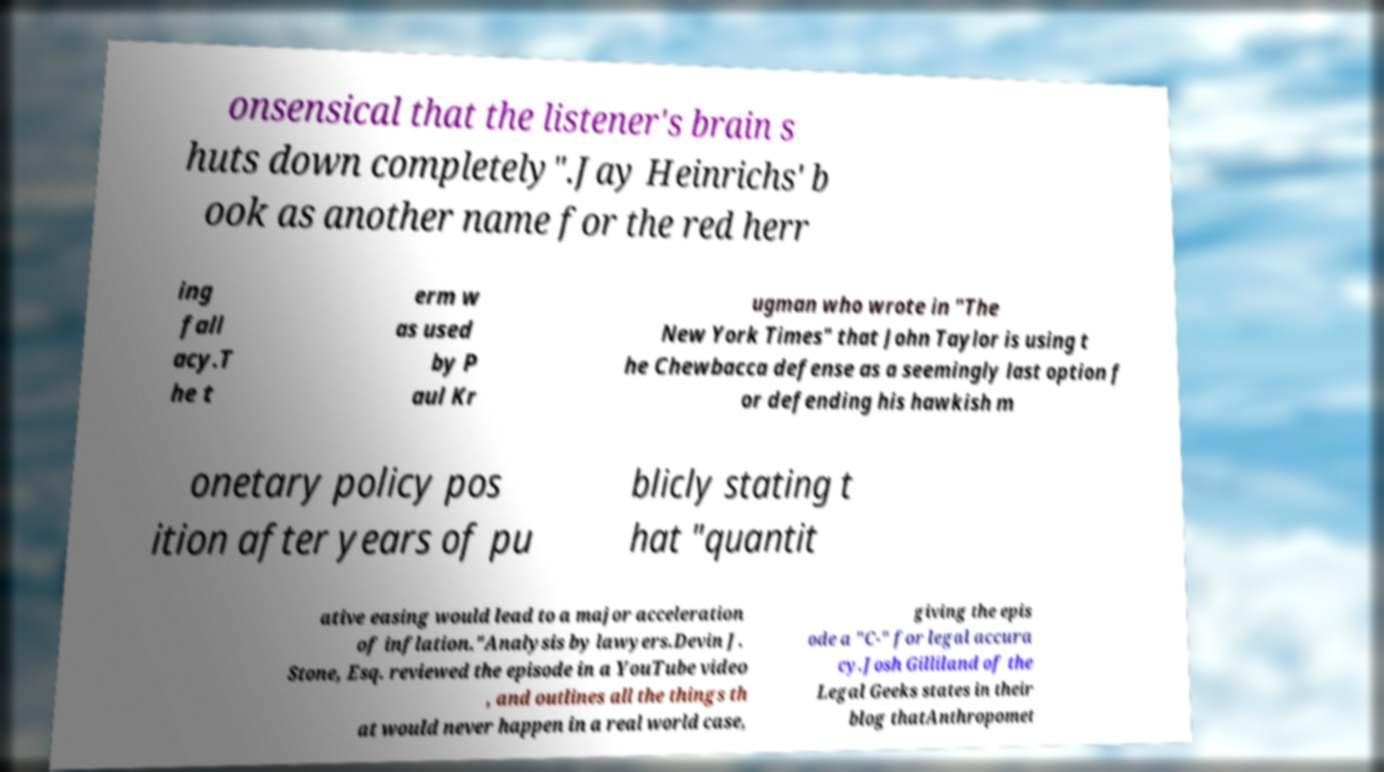There's text embedded in this image that I need extracted. Can you transcribe it verbatim? onsensical that the listener's brain s huts down completely".Jay Heinrichs' b ook as another name for the red herr ing fall acy.T he t erm w as used by P aul Kr ugman who wrote in "The New York Times" that John Taylor is using t he Chewbacca defense as a seemingly last option f or defending his hawkish m onetary policy pos ition after years of pu blicly stating t hat "quantit ative easing would lead to a major acceleration of inflation."Analysis by lawyers.Devin J. Stone, Esq. reviewed the episode in a YouTube video , and outlines all the things th at would never happen in a real world case, giving the epis ode a "C-" for legal accura cy.Josh Gilliland of the Legal Geeks states in their blog thatAnthropomet 